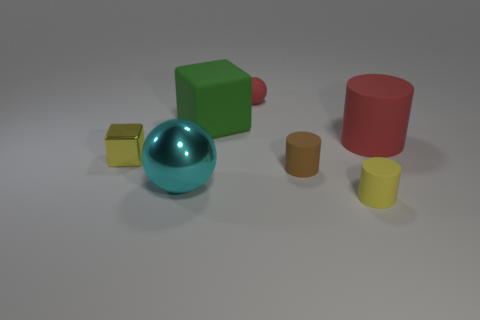Do the rubber sphere and the large shiny sphere have the same color?
Offer a terse response. No. What shape is the thing that is the same color as the tiny metallic block?
Your answer should be very brief. Cylinder. How many small yellow blocks have the same material as the tiny red thing?
Your answer should be compact. 0. What number of tiny brown matte cylinders are in front of the shiny block?
Ensure brevity in your answer.  1. The red rubber cylinder has what size?
Give a very brief answer. Large. What is the color of the other rubber cylinder that is the same size as the brown rubber cylinder?
Your response must be concise. Yellow. Is there a large rubber cylinder of the same color as the big metal sphere?
Give a very brief answer. No. What is the material of the tiny brown cylinder?
Provide a short and direct response. Rubber. How many large matte things are there?
Provide a succinct answer. 2. Does the cube that is in front of the red rubber cylinder have the same color as the small object that is behind the big green matte object?
Offer a terse response. No. 